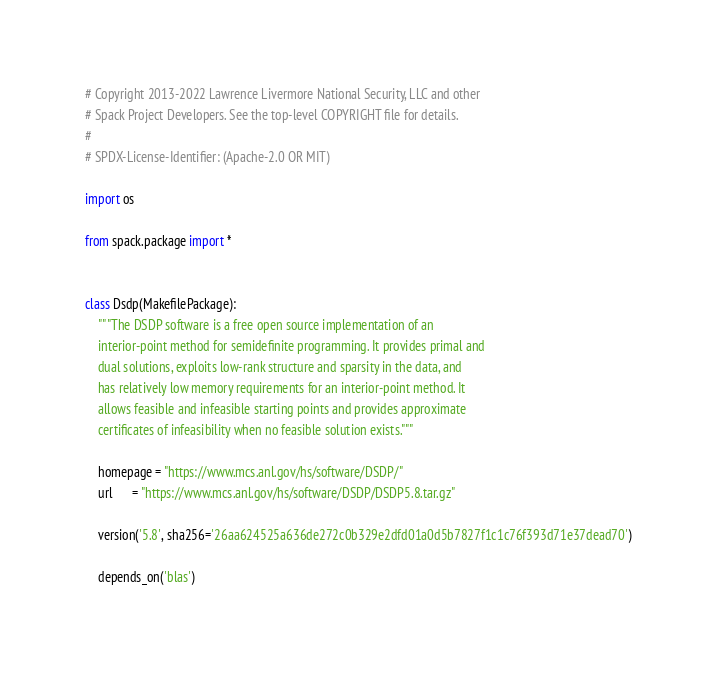<code> <loc_0><loc_0><loc_500><loc_500><_Python_># Copyright 2013-2022 Lawrence Livermore National Security, LLC and other
# Spack Project Developers. See the top-level COPYRIGHT file for details.
#
# SPDX-License-Identifier: (Apache-2.0 OR MIT)

import os

from spack.package import *


class Dsdp(MakefilePackage):
    """The DSDP software is a free open source implementation of an
    interior-point method for semidefinite programming. It provides primal and
    dual solutions, exploits low-rank structure and sparsity in the data, and
    has relatively low memory requirements for an interior-point method. It
    allows feasible and infeasible starting points and provides approximate
    certificates of infeasibility when no feasible solution exists."""

    homepage = "https://www.mcs.anl.gov/hs/software/DSDP/"
    url      = "https://www.mcs.anl.gov/hs/software/DSDP/DSDP5.8.tar.gz"

    version('5.8', sha256='26aa624525a636de272c0b329e2dfd01a0d5b7827f1c1c76f393d71e37dead70')

    depends_on('blas')</code> 